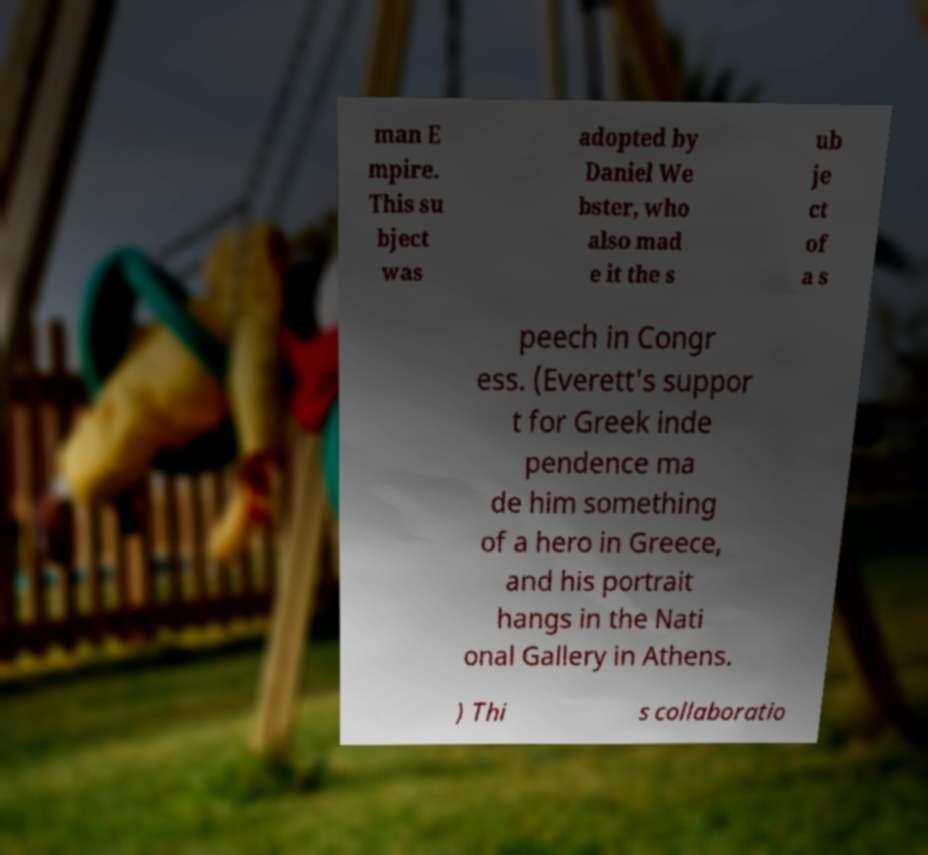What messages or text are displayed in this image? I need them in a readable, typed format. man E mpire. This su bject was adopted by Daniel We bster, who also mad e it the s ub je ct of a s peech in Congr ess. (Everett's suppor t for Greek inde pendence ma de him something of a hero in Greece, and his portrait hangs in the Nati onal Gallery in Athens. ) Thi s collaboratio 